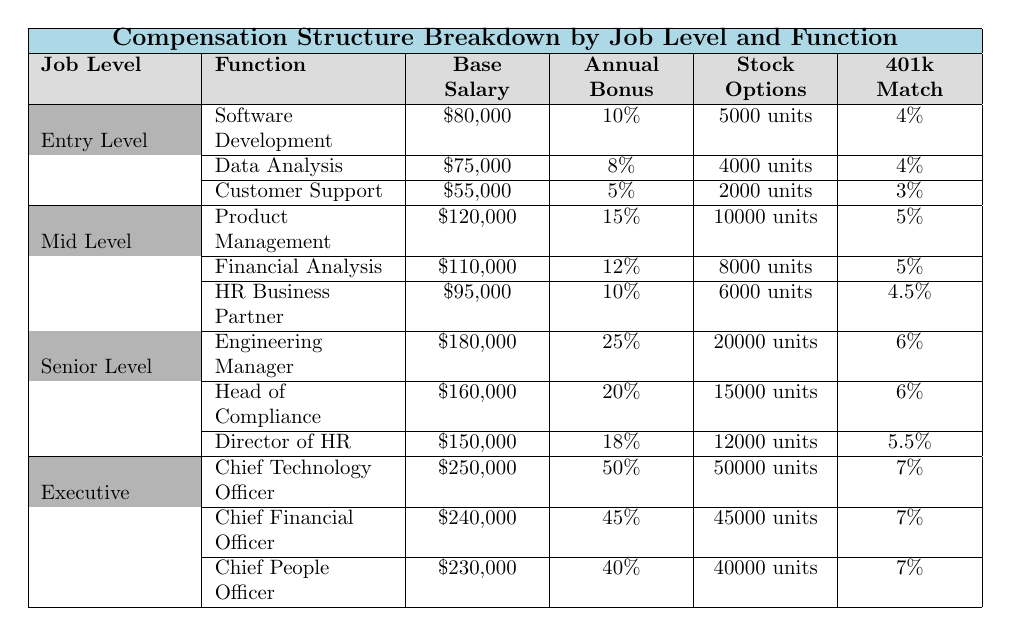What is the base salary for a Software Development position at the Entry Level? According to the table, the base salary for the Software Development position at Entry Level is listed directly. It shows \$80,000.
Answer: \$80,000 What percentage annual bonus is offered to HR Business Partners at Mid Level? The table states the annual bonus for HR Business Partners at the Mid Level is 10%.
Answer: 10% What is the difference in base salary between the Chief Technology Officer and the Chief People Officer? According to the table, the Chief Technology Officer has a base salary of \$250,000 and the Chief People Officer has a base salary of \$230,000. The difference is calculated as \$250,000 - \$230,000 = \$20,000.
Answer: \$20,000 What is the total base salary for all positions listed under Mid Level? The Mid Level positions' base salaries are \$120,000 (Product Management), \$110,000 (Financial Analysis), and \$95,000 (HR Business Partner). Adding them gives: \$120,000 + \$110,000 + \$95,000 = \$325,000.
Answer: \$325,000 Is the stock option value for the Engineering Manager higher than that of the Director of HR? The stock options for the Engineering Manager are 20,000 units, and for the Director of HR, it is 12,000 units. Comparing these values shows that 20,000 is greater than 12,000, thus the statement is true.
Answer: Yes What is the average annual bonus percentage for all positions at the Entry Level? The Entry Level positions have annual bonuses of 10% (Software Development), 8% (Data Analysis), and 5% (Customer Support). To find the average, sum these percentages: 10 + 8 + 5 = 23%, and then divide by the number of positions (3): 23% / 3 = 7.67%.
Answer: 7.67% Which job level has the highest base salary for any position listed? Examining all positions and corresponding base salaries shows that the Chief Technology Officer at the Executive level has the highest base salary of \$250,000 among all positions.
Answer: Chief Technology Officer What is the total number of stock options available for all positions at the Senior Level? The Senior Level positions have stock options of 20,000 (Engineering Manager), 15,000 (Head of Compliance), and 12,000 (Director of HR). Adding these together gives: 20,000 + 15,000 + 12,000 = 47,000 units.
Answer: 47,000 units Is the 401k match percentage the same for all functions at the Executive Level? The table lists the 401k match percentages for Executive Level positions as 7% across all three functions (Chief Technology Officer, Chief Financial Officer, and Chief People Officer). Thus, the statement is true.
Answer: Yes What is the total base salary for Entry Level functions combined? The base salaries for Entry Level positions are \$80,000 (Software Development), \$75,000 (Data Analysis), and \$55,000 (Customer Support). Summing these gives: \$80,000 + \$75,000 + \$55,000 = \$210,000.
Answer: \$210,000 